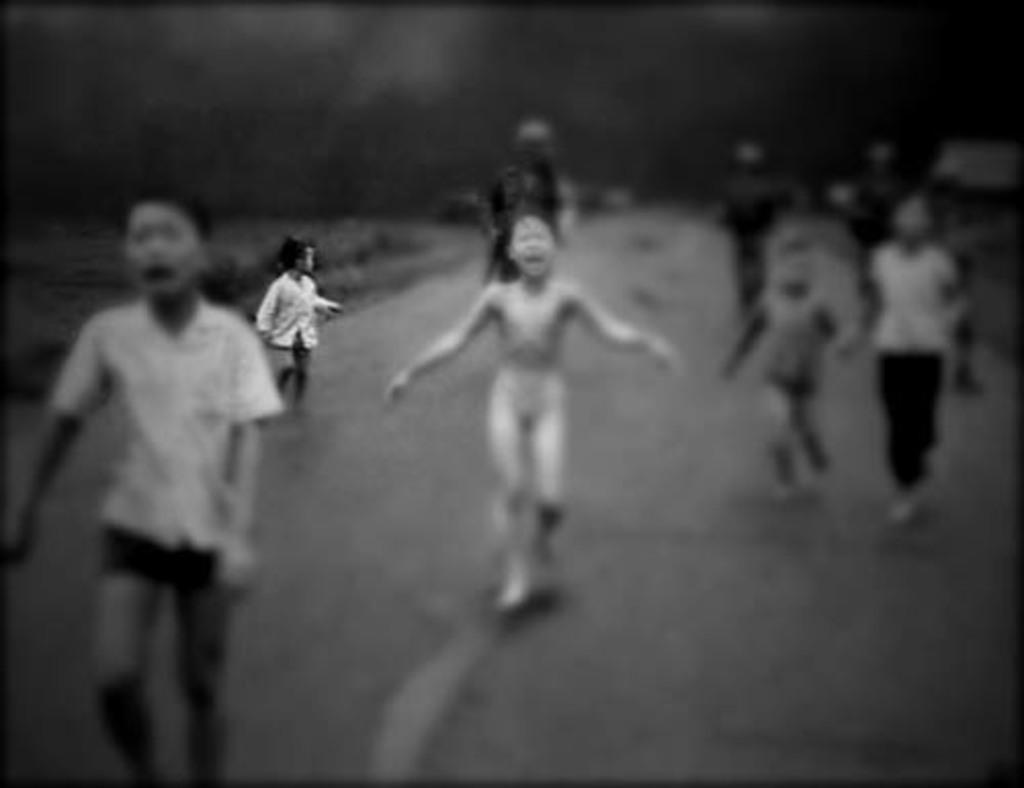Describe this image in one or two sentences. As we can see in the image there are few people and there is grass. The background is blurred and the image is little dark. 